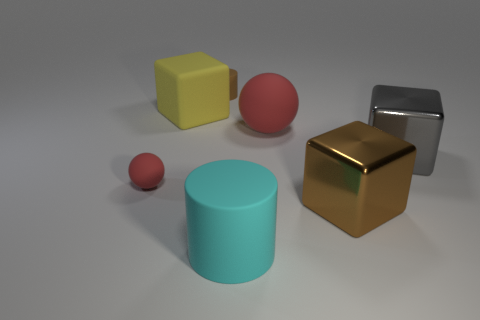There is another thing that is the same shape as the big red thing; what is its material?
Give a very brief answer. Rubber. Are there an equal number of large gray metallic blocks in front of the cyan thing and tiny rubber blocks?
Your answer should be very brief. Yes. There is a small ball to the left of the cube left of the brown shiny block; what color is it?
Provide a succinct answer. Red. What is the size of the rubber cylinder that is behind the ball that is right of the big yellow matte thing?
Make the answer very short. Small. There is a thing that is the same color as the big ball; what is its size?
Provide a succinct answer. Small. How many other things are the same size as the cyan cylinder?
Give a very brief answer. 4. There is a big metal cube that is in front of the small object that is on the left side of the cylinder behind the big yellow block; what is its color?
Provide a succinct answer. Brown. What number of other objects are there of the same shape as the large cyan object?
Your response must be concise. 1. There is a red thing in front of the gray metallic cube; what shape is it?
Provide a succinct answer. Sphere. There is a brown thing on the left side of the big red rubber sphere; is there a thing in front of it?
Provide a succinct answer. Yes. 